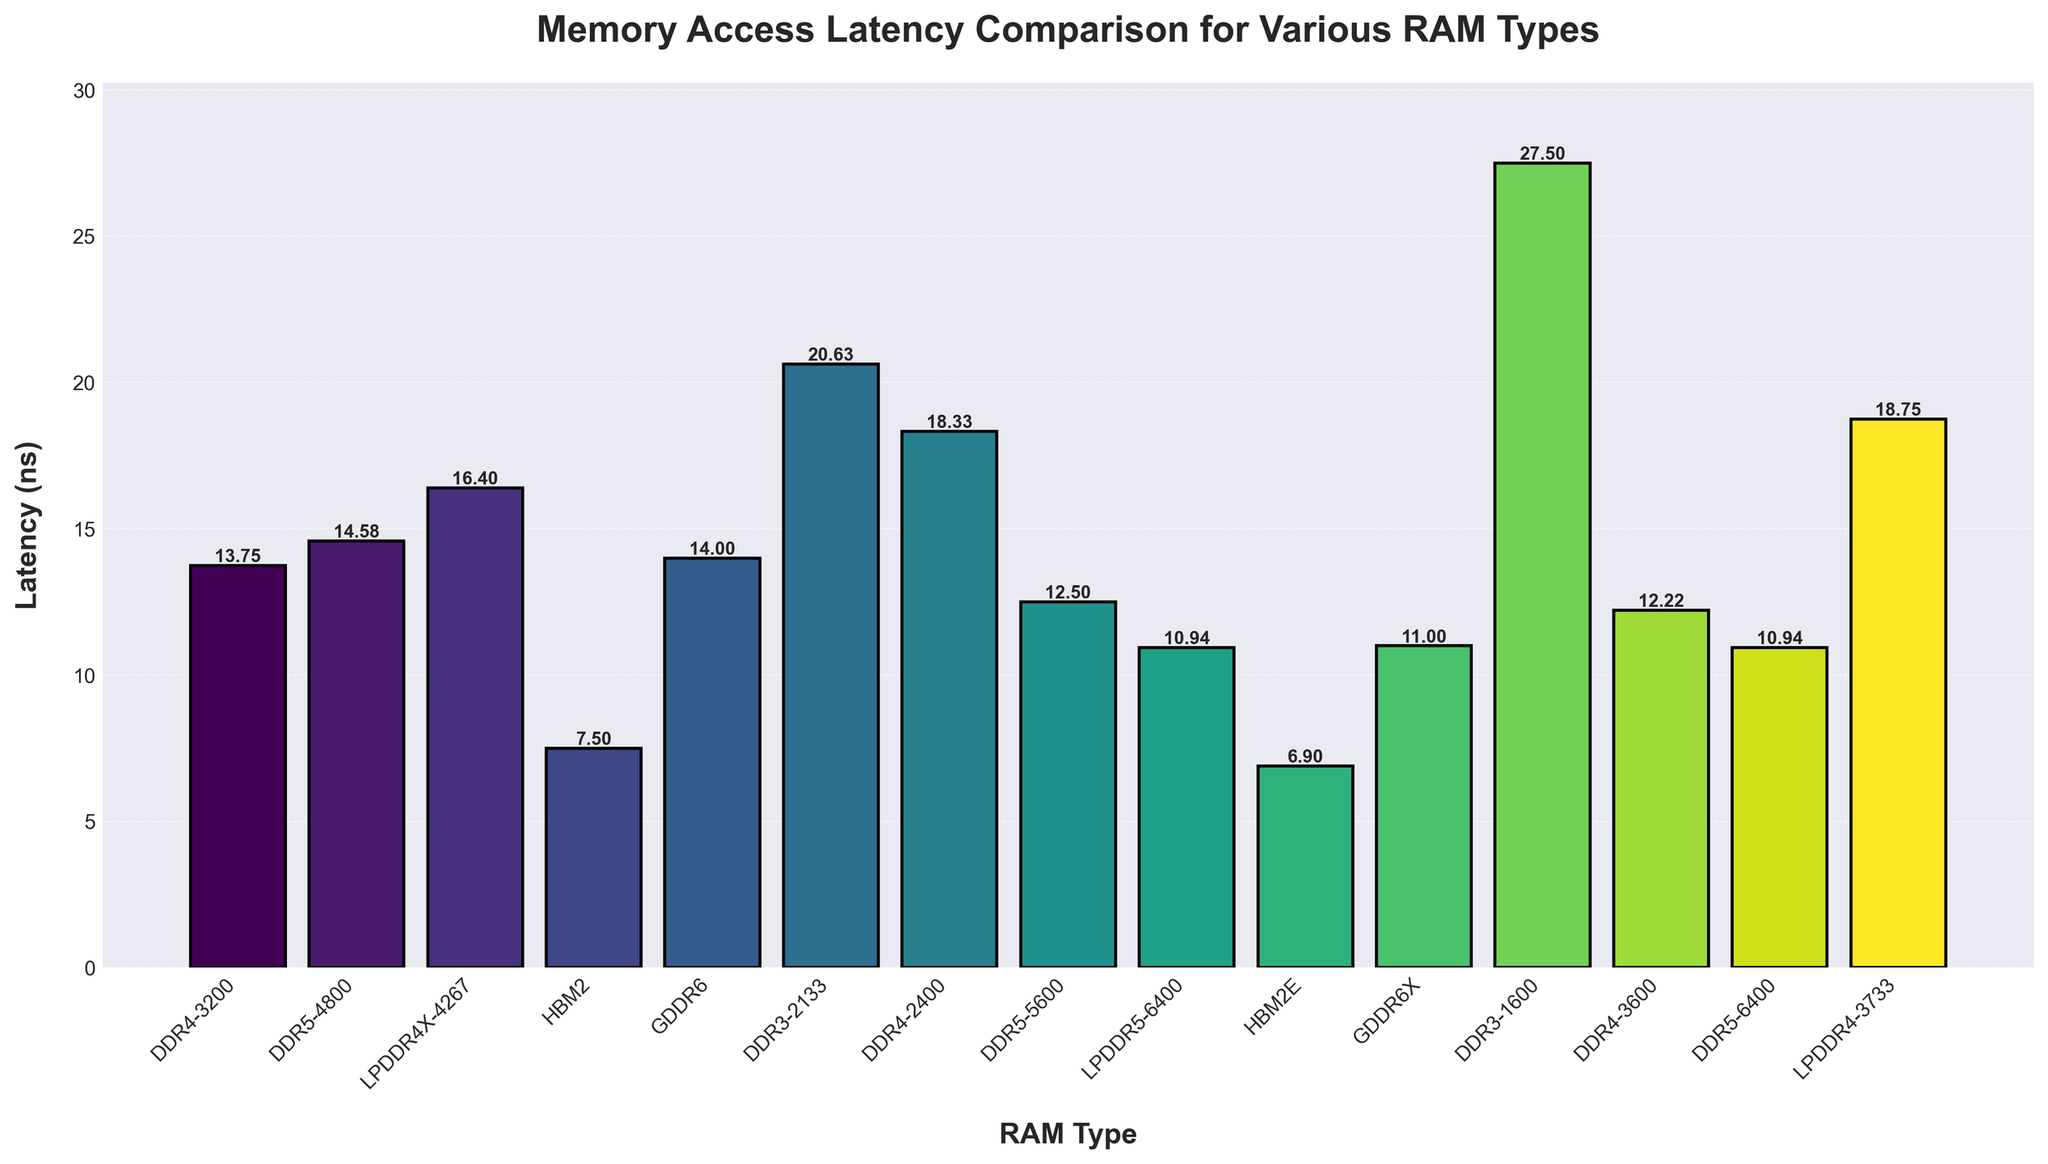Which RAM type has the lowest memory access latency? By visually identifying the bar with the shortest height, we see that "HBM2E" has the shortest bar, indicating the lowest latency.
Answer: HBM2E What is the latency difference between DDR3-1600 and DDR4-3600? First, identify the heights of the bars for DDR3-1600 and DDR4-3600, which are 27.50 ns and 12.22 ns, respectively. Calculate the difference: 27.50 - 12.22 = 15.28 ns.
Answer: 15.28 ns Which RAM type has the highest memory access latency? By visually identifying the bar with the greatest height, we see that "DDR3-1600" has the tallest bar, indicating the highest latency.
Answer: DDR3-1600 What is the average latency of DDR4-3200, DDR4-3600, and DDR5-5600? Identify the latencies: DDR4-3200 is 13.75 ns, DDR4-3600 is 12.22 ns, and DDR5-5600 is 12.50 ns. Calculate the average: (13.75 + 12.22 + 12.50) / 3 ≈ 12.82 ns.
Answer: 12.82 ns Compare the memory access latencies of LPDDR5-6400 and GDDR6X. Which is faster and by how much? Identify the latencies: LPDDR5-6400 is 10.94 ns and GDDR6X is 11.00 ns. Subtract the smaller from the larger: 11.00 - 10.94 = 0.06 ns. LPDDR5-6400 is faster by 0.06 ns.
Answer: LPDDR5-6400 by 0.06 ns How does the latency of DDR5-4800 compare to DDR5-6400? Identify the latencies: DDR5-4800 is 14.58 ns and DDR5-6400 is 10.94 ns. Subtract the smaller from the larger: 14.58 - 10.94 = 3.64 ns.
Answer: DDR5-4800 is 3.64 ns slower What is the combined latency of LPDDR4X-4267 and HBM2E? Identify the latencies: LPDDR4X-4267 is 16.40 ns and HBM2E is 6.90 ns. Add them together: 16.40 + 6.90 = 23.30 ns.
Answer: 23.30 ns Which has a shorter latency: DDR4-2400 or LPDDR4-3733 and by how much? Identify the latencies: DDR4-2400 is 18.33 ns and LPDDR4-3733 is 18.75 ns. Subtract the smaller from the larger: 18.75 - 18.33 = 0.42 ns.
Answer: DDR4-2400 by 0.42 ns What is the median latency of the given RAM types? Arrange the latencies in ascending order: 6.90, 7.50, 10.94, 10.94, 11.00, 12.22, 12.50, 13.75, 14.00, 14.58, 16.40, 18.33, 18.75, 20.63, 27.50. The middle value (8th entry) is 13.75 ns.
Answer: 13.75 ns Which RAM type has a darker color: DDR4-2400 or DDR3-2133? By visually comparing the colors used to represent the bars, DDR4-2400 has a darker color than DDR3-2133.
Answer: DDR4-2400 